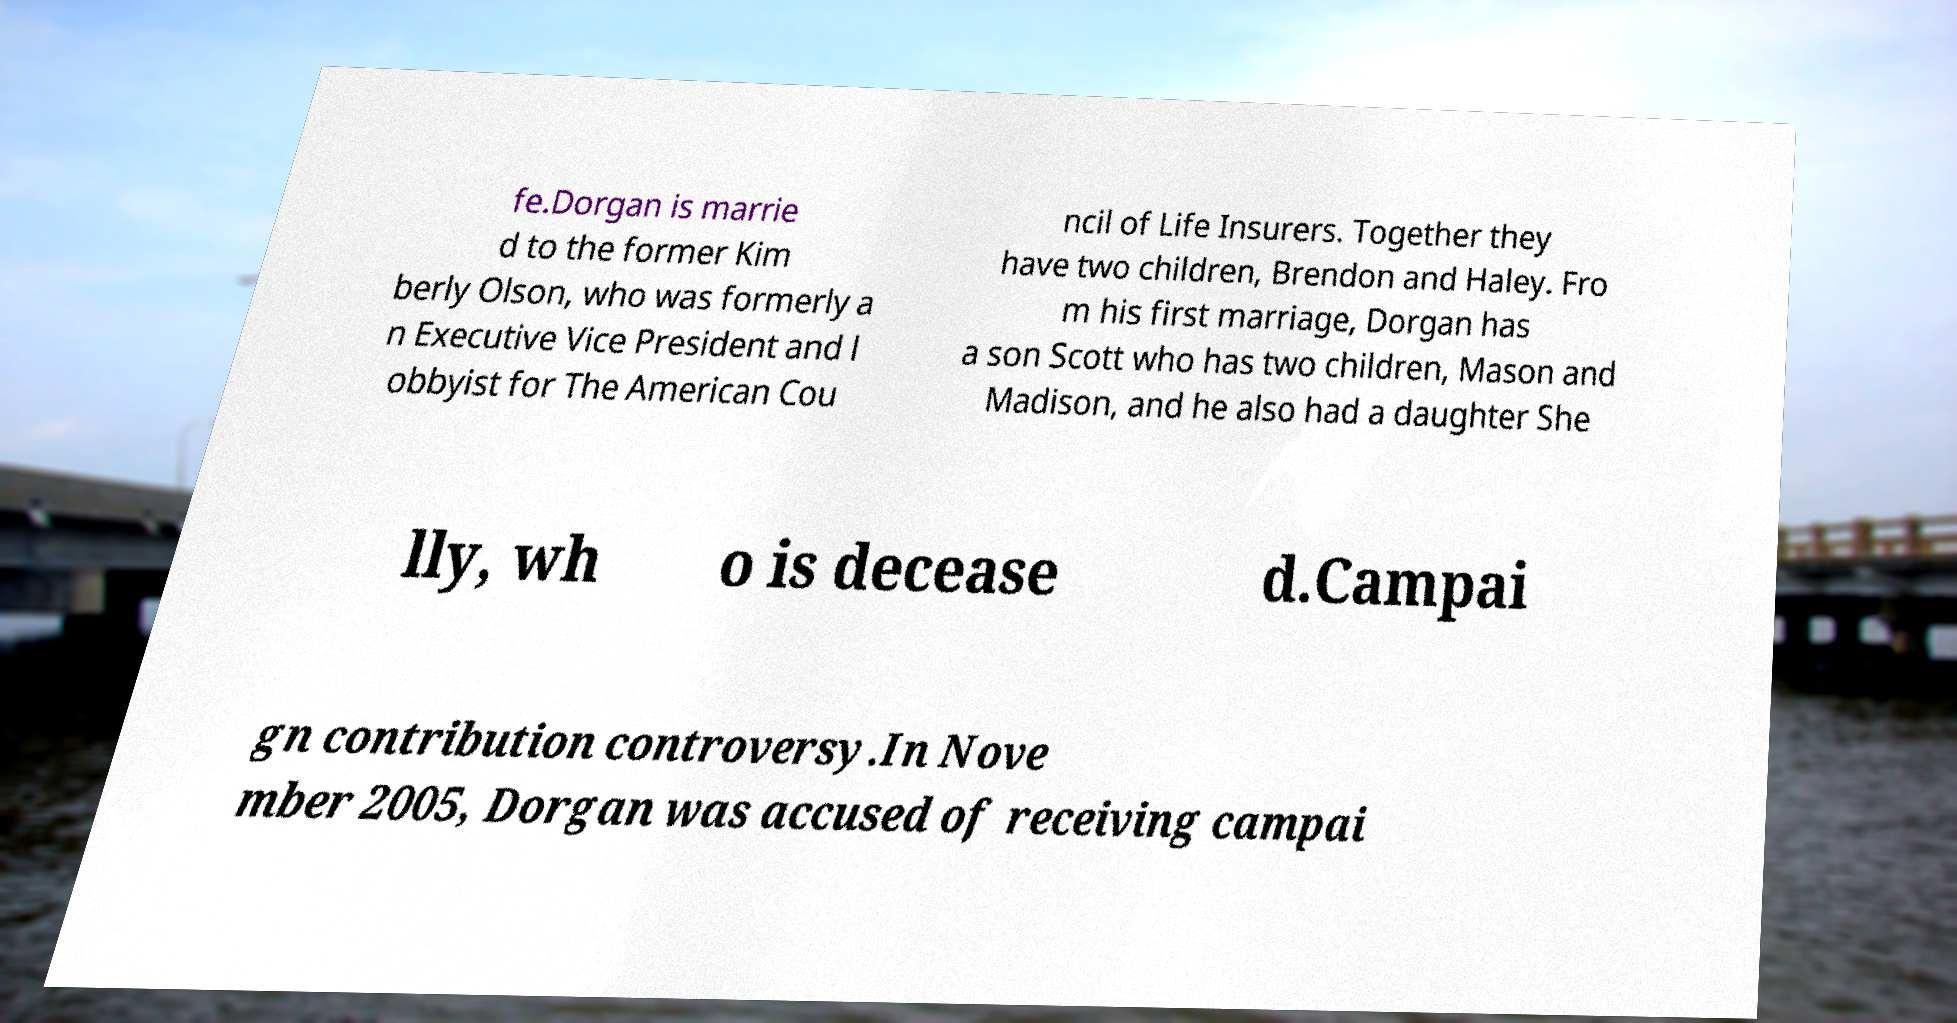Please read and relay the text visible in this image. What does it say? fe.Dorgan is marrie d to the former Kim berly Olson, who was formerly a n Executive Vice President and l obbyist for The American Cou ncil of Life Insurers. Together they have two children, Brendon and Haley. Fro m his first marriage, Dorgan has a son Scott who has two children, Mason and Madison, and he also had a daughter She lly, wh o is decease d.Campai gn contribution controversy.In Nove mber 2005, Dorgan was accused of receiving campai 